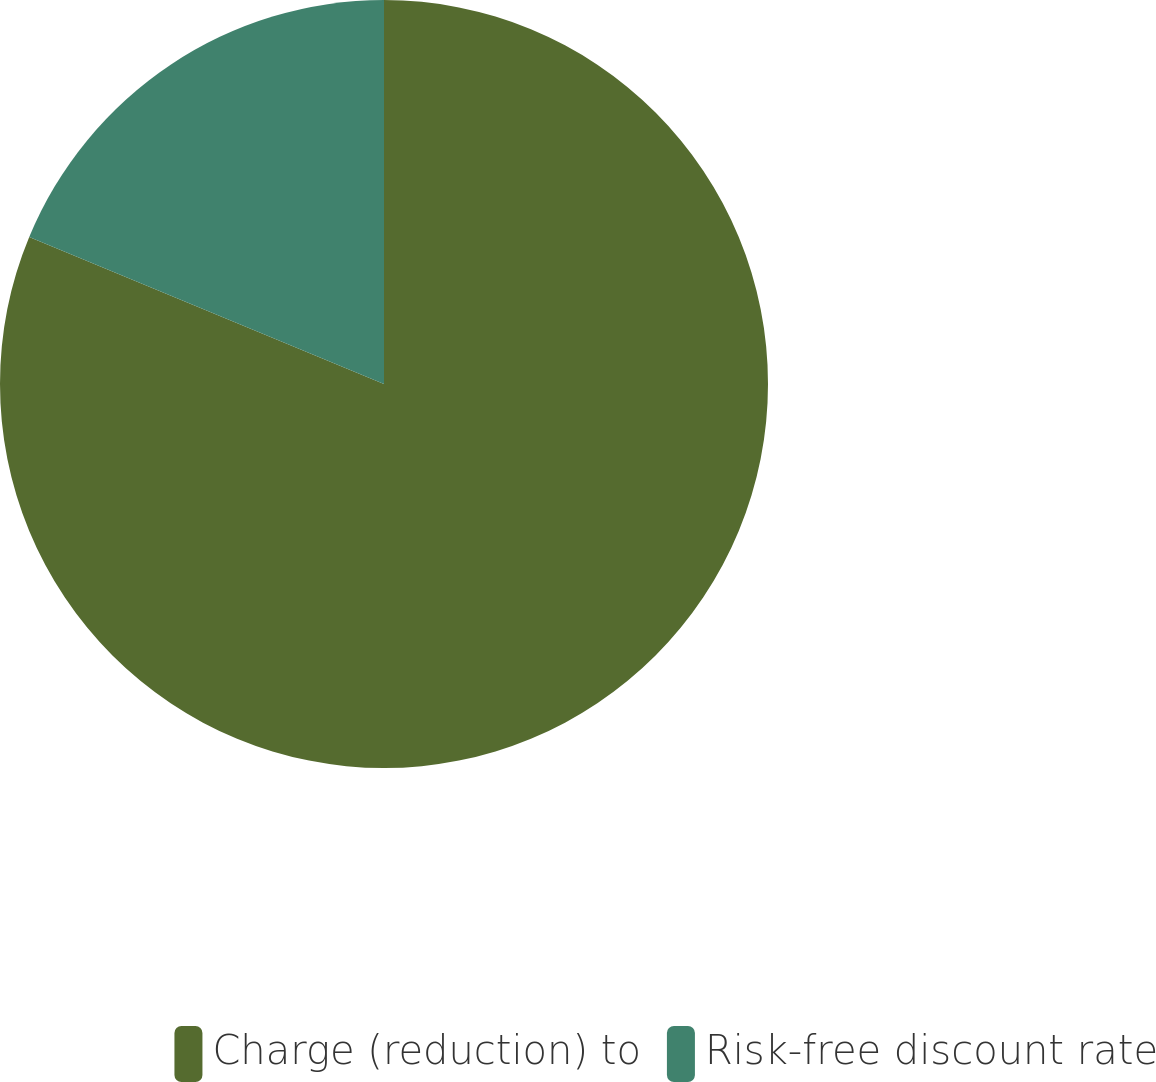Convert chart. <chart><loc_0><loc_0><loc_500><loc_500><pie_chart><fcel>Charge (reduction) to<fcel>Risk-free discount rate<nl><fcel>81.25%<fcel>18.75%<nl></chart> 